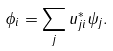Convert formula to latex. <formula><loc_0><loc_0><loc_500><loc_500>\phi _ { i } = \sum _ { j } u _ { j i } ^ { * } \psi _ { j } .</formula> 